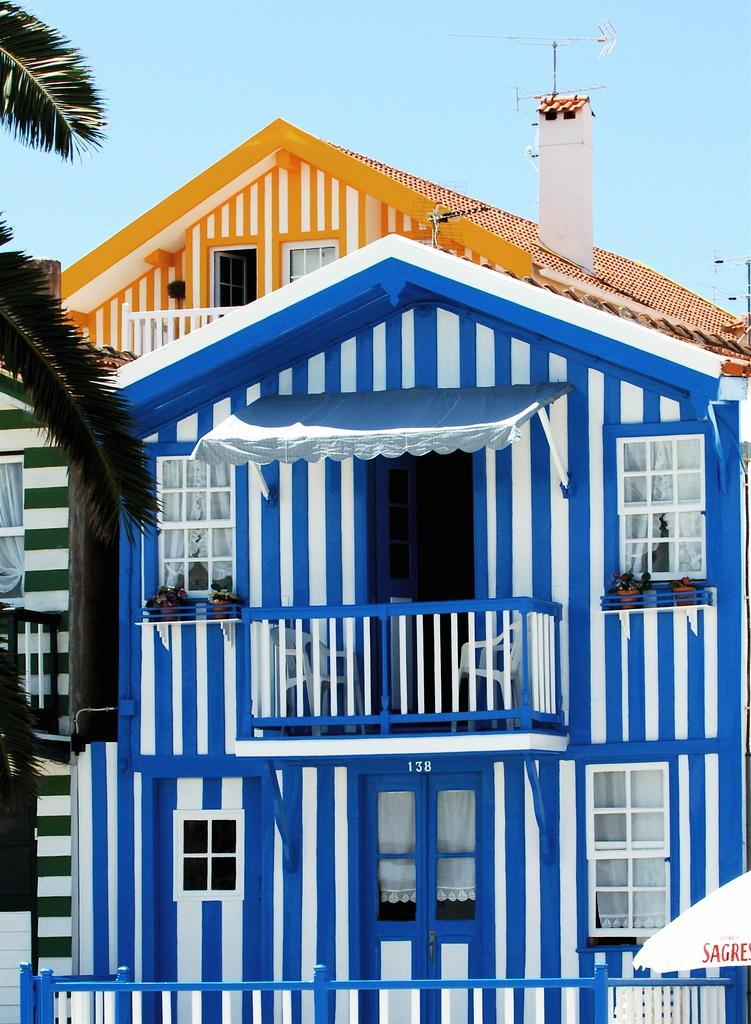Please provide a concise description of this image. In this image there is a building, for that building there are windows and doors, in the top left there is a tree, in the background there is a sky. 